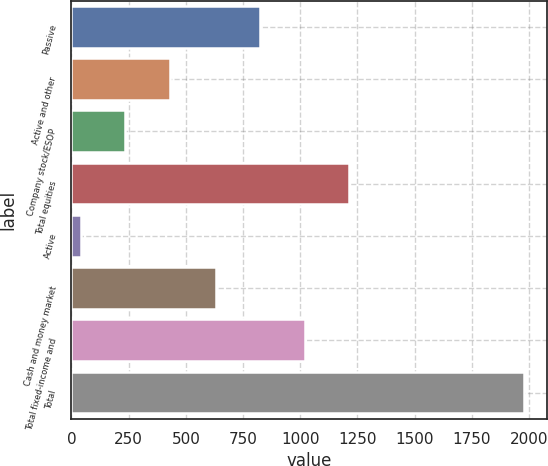Convert chart to OTSL. <chart><loc_0><loc_0><loc_500><loc_500><bar_chart><fcel>Passive<fcel>Active and other<fcel>Company stock/ESOP<fcel>Total equities<fcel>Active<fcel>Cash and money market<fcel>Total fixed-income and<fcel>Total<nl><fcel>825.8<fcel>428.6<fcel>234.8<fcel>1213.4<fcel>41<fcel>632<fcel>1019.6<fcel>1979<nl></chart> 